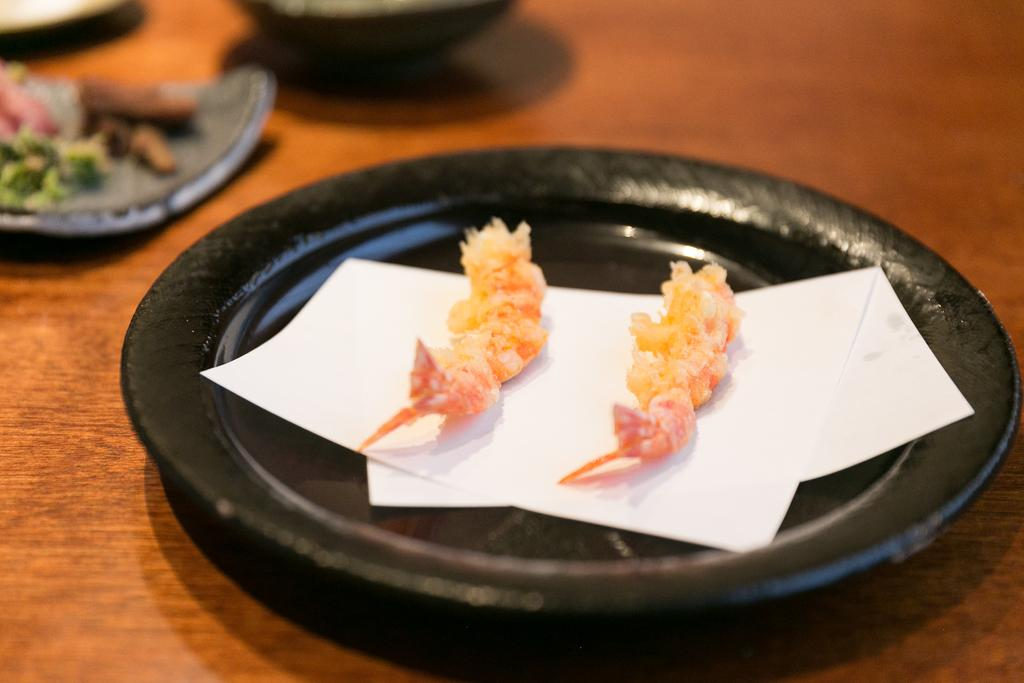What piece of furniture is present in the image? There is a table in the image. What is placed on the table? There are plates on the table. What is inside the plates? There is food and papers in the plates. How many bikes are parked next to the table in the image? There are no bikes present in the image. What is the relationship between the people in the image, considering the presence of hate or crush? There is no indication of any relationship between people in the image, nor is there any mention of hate or crush. 